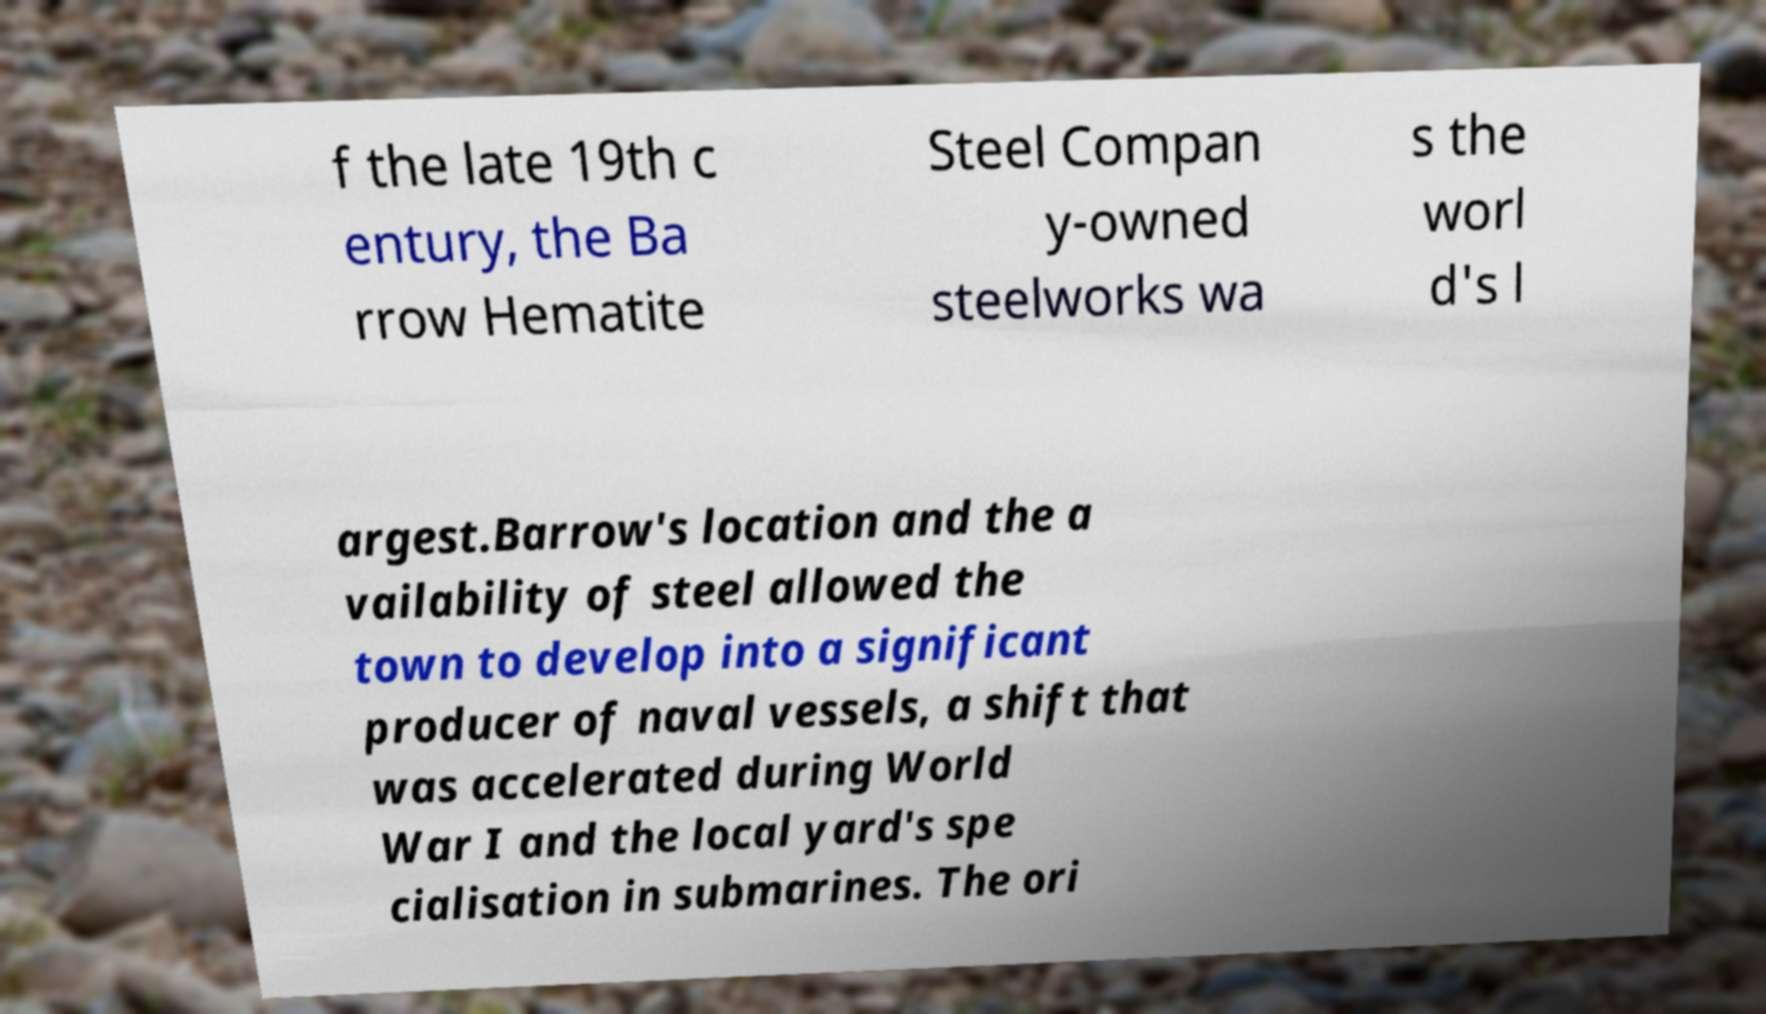What messages or text are displayed in this image? I need them in a readable, typed format. f the late 19th c entury, the Ba rrow Hematite Steel Compan y-owned steelworks wa s the worl d's l argest.Barrow's location and the a vailability of steel allowed the town to develop into a significant producer of naval vessels, a shift that was accelerated during World War I and the local yard's spe cialisation in submarines. The ori 